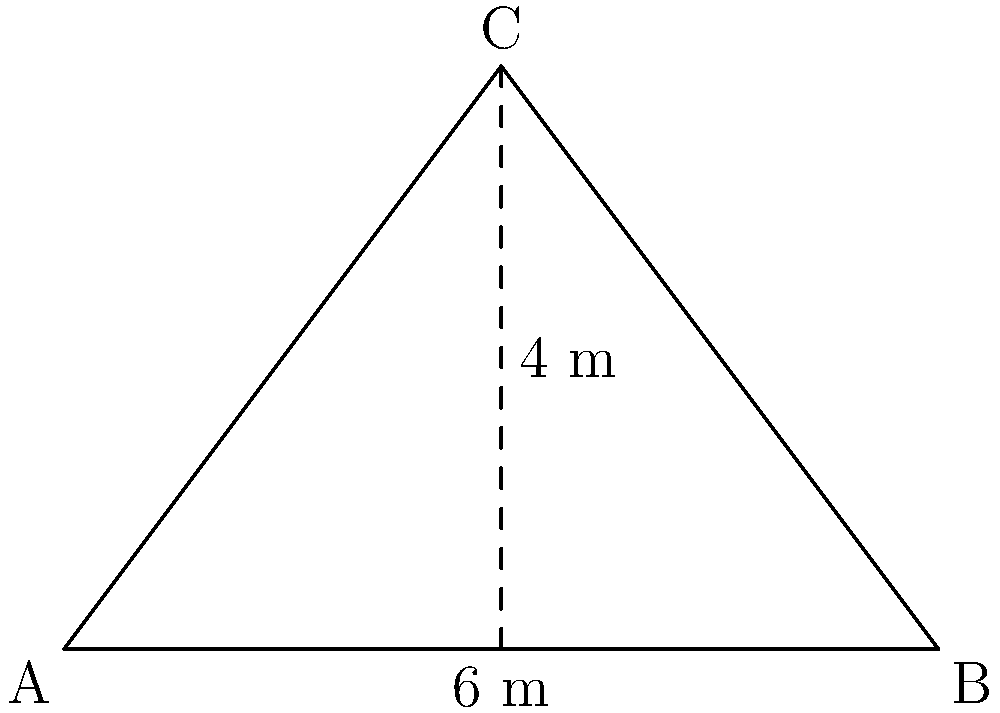A new billboard for your latest business venture is being installed along the highway. The billboard has a triangular shape with a base of 6 meters and a height of 4 meters. What is the area of this billboard in square meters? Let's approach this step-by-step:

1) The formula for the area of a triangle is:

   $$A = \frac{1}{2} \times base \times height$$

2) We're given:
   - Base = 6 meters
   - Height = 4 meters

3) Let's plug these values into our formula:

   $$A = \frac{1}{2} \times 6 \times 4$$

4) Now, let's calculate:
   
   $$A = \frac{1}{2} \times 24 = 12$$

5) Therefore, the area of the billboard is 12 square meters.

This calculation gives us the exact surface area available for your advertisement, helping you determine how much space you have for your marketing message and potentially how much you should be charged for this billboard space.
Answer: 12 m² 